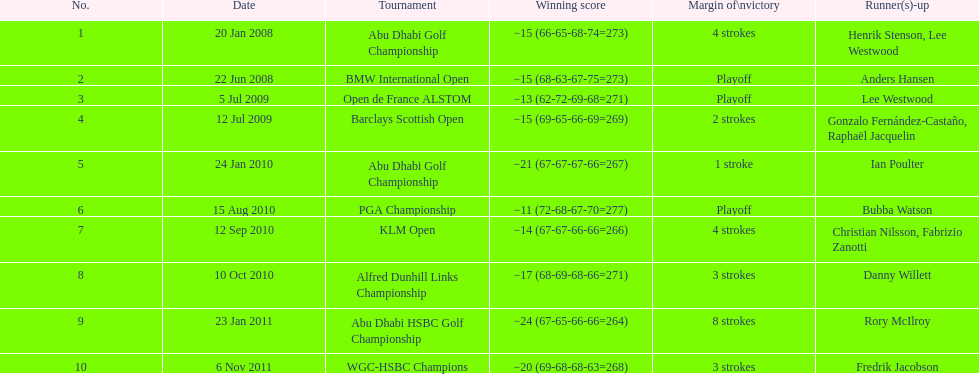How many extra strokes were there in the klm open in comparison to the barclays scottish open? 2 strokes. 